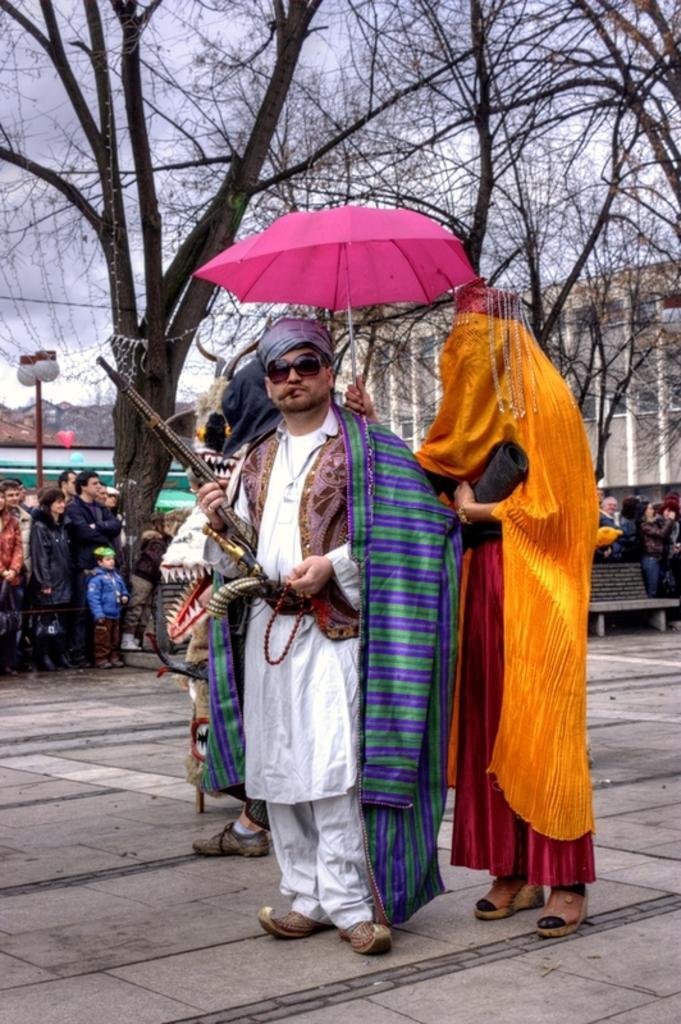Can you describe this image briefly? In this image there are people standing wearing costumes and holding a gun and an umbrella in their hands, in the background there are people standing and there are trees buildings and the sky. 